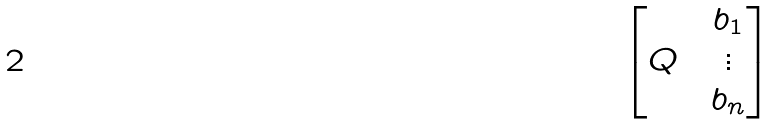<formula> <loc_0><loc_0><loc_500><loc_500>\begin{bmatrix} & & b _ { 1 } \\ Q & & \vdots \\ & & b _ { n } \\ \end{bmatrix}</formula> 